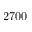Convert formula to latex. <formula><loc_0><loc_0><loc_500><loc_500>2 7 0 0</formula> 